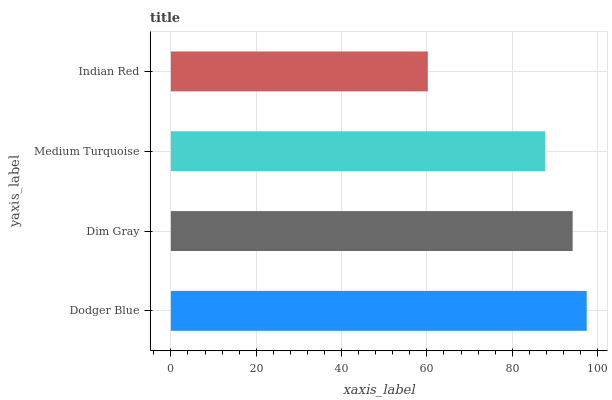Is Indian Red the minimum?
Answer yes or no. Yes. Is Dodger Blue the maximum?
Answer yes or no. Yes. Is Dim Gray the minimum?
Answer yes or no. No. Is Dim Gray the maximum?
Answer yes or no. No. Is Dodger Blue greater than Dim Gray?
Answer yes or no. Yes. Is Dim Gray less than Dodger Blue?
Answer yes or no. Yes. Is Dim Gray greater than Dodger Blue?
Answer yes or no. No. Is Dodger Blue less than Dim Gray?
Answer yes or no. No. Is Dim Gray the high median?
Answer yes or no. Yes. Is Medium Turquoise the low median?
Answer yes or no. Yes. Is Medium Turquoise the high median?
Answer yes or no. No. Is Dim Gray the low median?
Answer yes or no. No. 